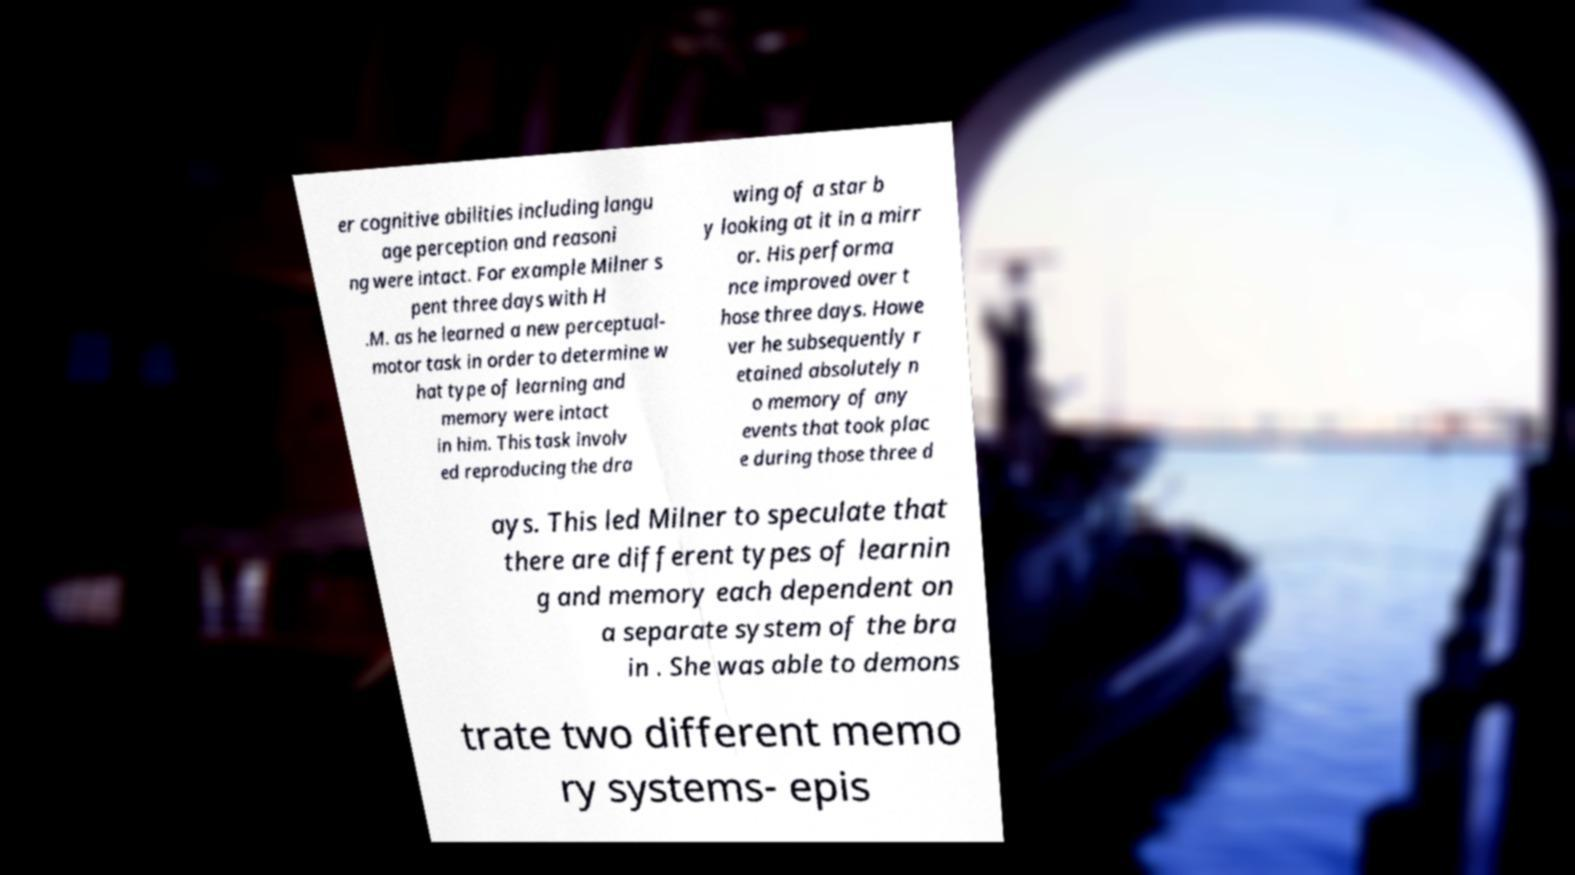Please identify and transcribe the text found in this image. er cognitive abilities including langu age perception and reasoni ng were intact. For example Milner s pent three days with H .M. as he learned a new perceptual- motor task in order to determine w hat type of learning and memory were intact in him. This task involv ed reproducing the dra wing of a star b y looking at it in a mirr or. His performa nce improved over t hose three days. Howe ver he subsequently r etained absolutely n o memory of any events that took plac e during those three d ays. This led Milner to speculate that there are different types of learnin g and memory each dependent on a separate system of the bra in . She was able to demons trate two different memo ry systems- epis 